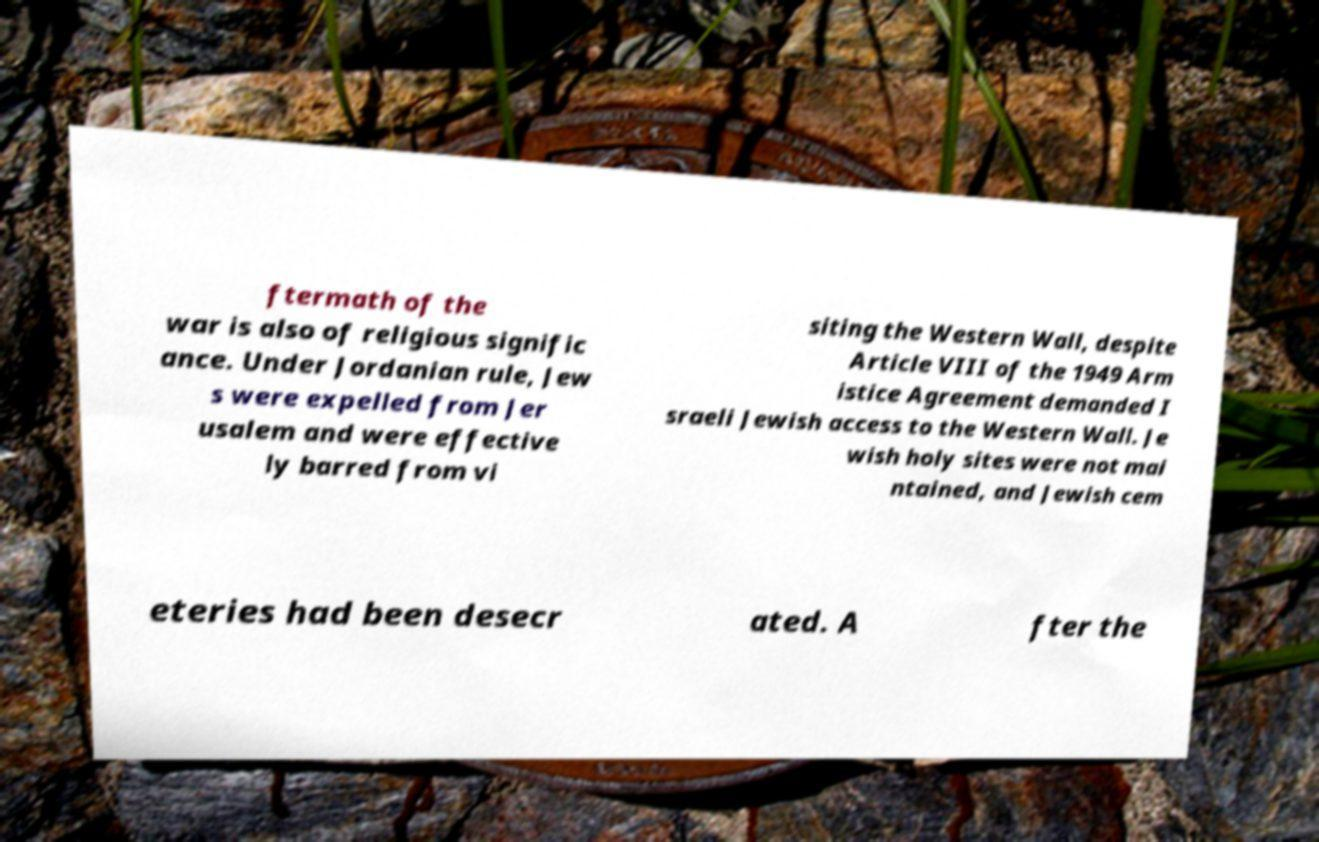Can you read and provide the text displayed in the image?This photo seems to have some interesting text. Can you extract and type it out for me? ftermath of the war is also of religious signific ance. Under Jordanian rule, Jew s were expelled from Jer usalem and were effective ly barred from vi siting the Western Wall, despite Article VIII of the 1949 Arm istice Agreement demanded I sraeli Jewish access to the Western Wall. Je wish holy sites were not mai ntained, and Jewish cem eteries had been desecr ated. A fter the 